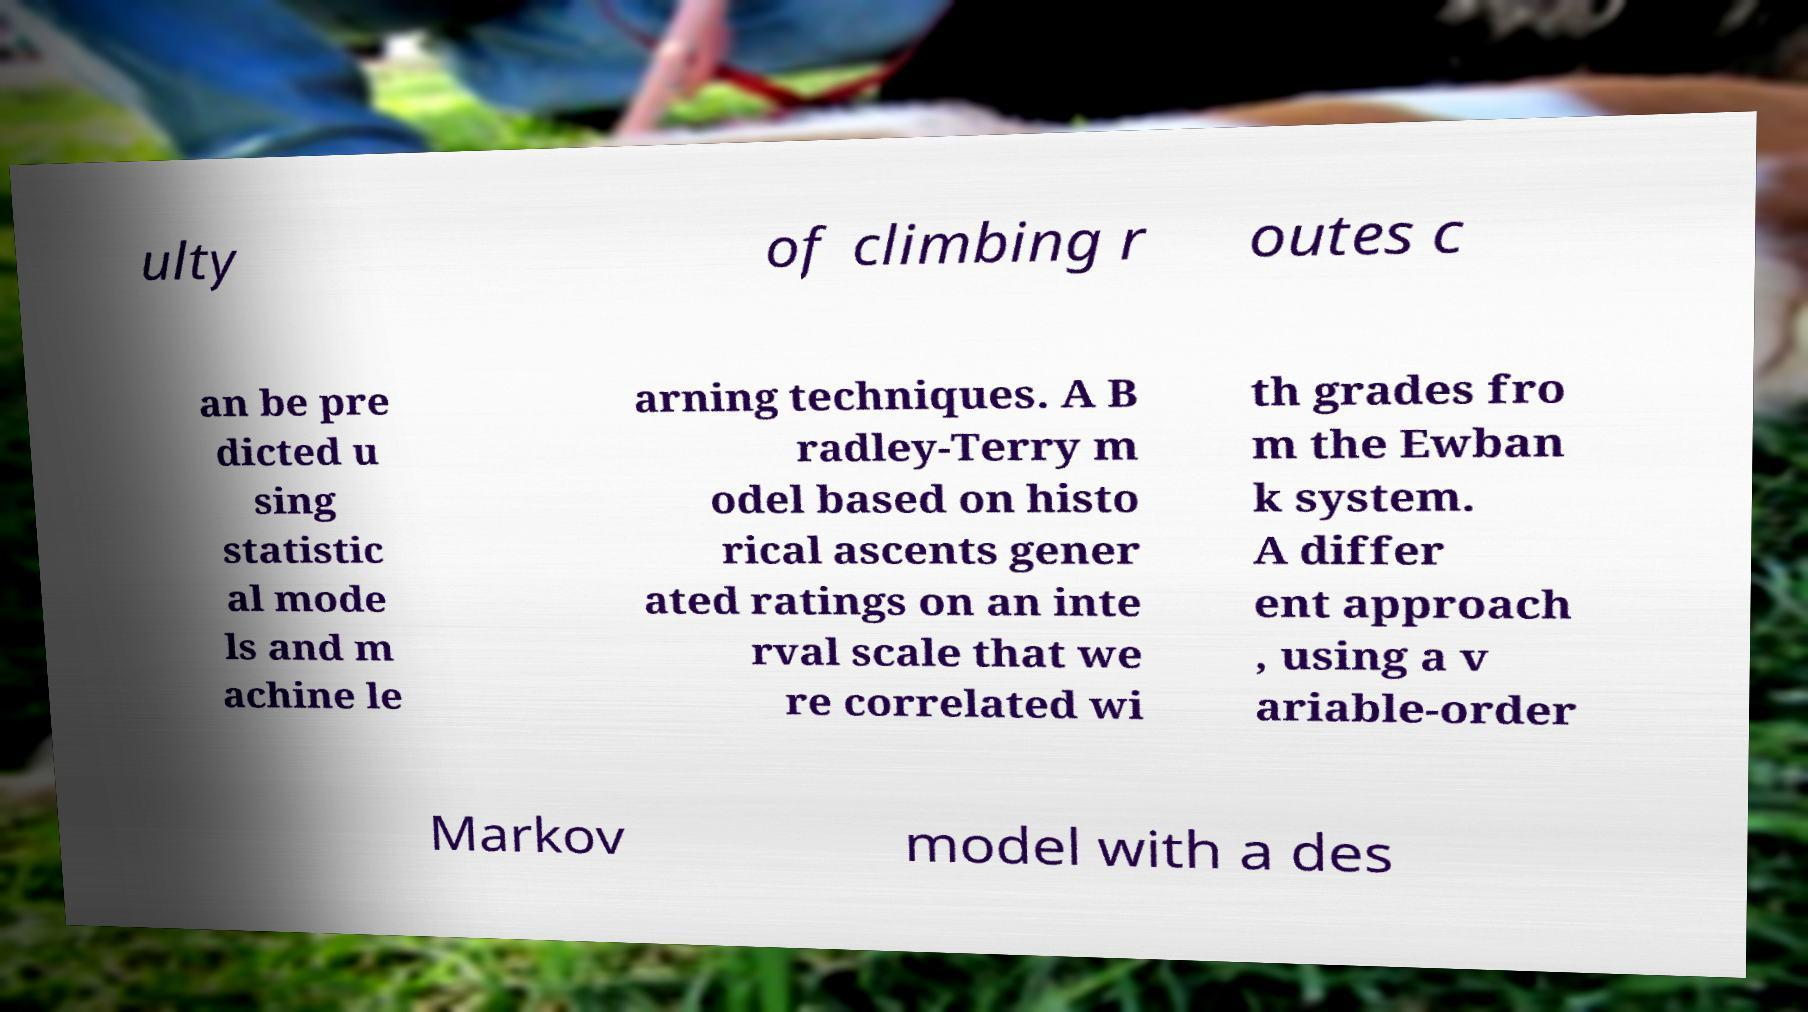For documentation purposes, I need the text within this image transcribed. Could you provide that? ulty of climbing r outes c an be pre dicted u sing statistic al mode ls and m achine le arning techniques. A B radley-Terry m odel based on histo rical ascents gener ated ratings on an inte rval scale that we re correlated wi th grades fro m the Ewban k system. A differ ent approach , using a v ariable-order Markov model with a des 